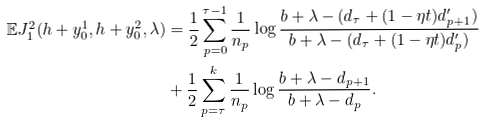Convert formula to latex. <formula><loc_0><loc_0><loc_500><loc_500>\mathbb { E } J _ { 1 } ^ { 2 } ( h + y _ { 0 } ^ { 1 } , h + y _ { 0 } ^ { 2 } , \lambda ) & = \frac { 1 } { 2 } \sum _ { p = 0 } ^ { \tau - 1 } \frac { 1 } { n _ { p } } \log \frac { b + \lambda - ( d _ { \tau } + ( 1 - \eta t ) d _ { p + 1 } ^ { \prime } ) } { b + \lambda - ( d _ { \tau } + ( 1 - \eta t ) d _ { p } ^ { \prime } ) } \\ & + \frac { 1 } { 2 } \sum _ { p = \tau } ^ { k } \frac { 1 } { n _ { p } } \log \frac { b + \lambda - d _ { p + 1 } } { b + \lambda - d _ { p } } .</formula> 